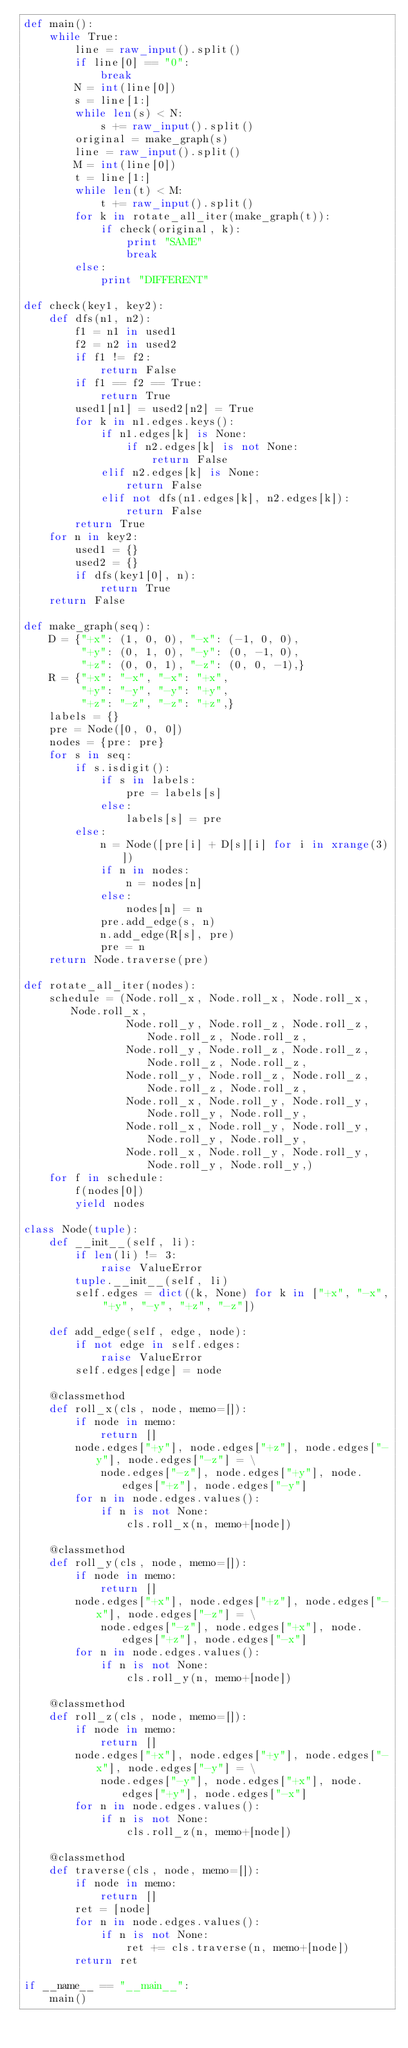<code> <loc_0><loc_0><loc_500><loc_500><_Python_>def main():
    while True:
        line = raw_input().split()
        if line[0] == "0":
            break
        N = int(line[0])
        s = line[1:]
        while len(s) < N:
            s += raw_input().split()
        original = make_graph(s)
        line = raw_input().split()
        M = int(line[0])
        t = line[1:]
        while len(t) < M:
            t += raw_input().split()
        for k in rotate_all_iter(make_graph(t)):
            if check(original, k):
                print "SAME"
                break
        else:
            print "DIFFERENT"

def check(key1, key2):
    def dfs(n1, n2):
        f1 = n1 in used1
        f2 = n2 in used2
        if f1 != f2:
            return False
        if f1 == f2 == True:
            return True
        used1[n1] = used2[n2] = True
        for k in n1.edges.keys():
            if n1.edges[k] is None:
                if n2.edges[k] is not None:
                    return False
            elif n2.edges[k] is None:
                return False
            elif not dfs(n1.edges[k], n2.edges[k]):
                return False
        return True
    for n in key2:
        used1 = {}
        used2 = {}
        if dfs(key1[0], n):
            return True
    return False

def make_graph(seq):
    D = {"+x": (1, 0, 0), "-x": (-1, 0, 0),
         "+y": (0, 1, 0), "-y": (0, -1, 0),
         "+z": (0, 0, 1), "-z": (0, 0, -1),}
    R = {"+x": "-x", "-x": "+x",
         "+y": "-y", "-y": "+y",
         "+z": "-z", "-z": "+z",}
    labels = {}
    pre = Node([0, 0, 0])
    nodes = {pre: pre}
    for s in seq:
        if s.isdigit():
            if s in labels:
                pre = labels[s]
            else:
                labels[s] = pre
        else:
            n = Node([pre[i] + D[s][i] for i in xrange(3)])
            if n in nodes:
                n = nodes[n]
            else:
                nodes[n] = n
            pre.add_edge(s, n)
            n.add_edge(R[s], pre)
            pre = n
    return Node.traverse(pre)

def rotate_all_iter(nodes):
    schedule = (Node.roll_x, Node.roll_x, Node.roll_x, Node.roll_x, 
                Node.roll_y, Node.roll_z, Node.roll_z, Node.roll_z, Node.roll_z,
                Node.roll_y, Node.roll_z, Node.roll_z, Node.roll_z, Node.roll_z,
                Node.roll_y, Node.roll_z, Node.roll_z, Node.roll_z, Node.roll_z,
                Node.roll_x, Node.roll_y, Node.roll_y, Node.roll_y, Node.roll_y,
                Node.roll_x, Node.roll_y, Node.roll_y, Node.roll_y, Node.roll_y,
                Node.roll_x, Node.roll_y, Node.roll_y, Node.roll_y, Node.roll_y,)
    for f in schedule:
        f(nodes[0])
        yield nodes

class Node(tuple):
    def __init__(self, li):
        if len(li) != 3:
            raise ValueError
        tuple.__init__(self, li)
        self.edges = dict((k, None) for k in ["+x", "-x", "+y", "-y", "+z", "-z"])
        
    def add_edge(self, edge, node):
        if not edge in self.edges:
            raise ValueError
        self.edges[edge] = node

    @classmethod
    def roll_x(cls, node, memo=[]):
        if node in memo:
            return []
        node.edges["+y"], node.edges["+z"], node.edges["-y"], node.edges["-z"] = \
            node.edges["-z"], node.edges["+y"], node.edges["+z"], node.edges["-y"]
        for n in node.edges.values():
            if n is not None:
                cls.roll_x(n, memo+[node])

    @classmethod
    def roll_y(cls, node, memo=[]):
        if node in memo:
            return []
        node.edges["+x"], node.edges["+z"], node.edges["-x"], node.edges["-z"] = \
            node.edges["-z"], node.edges["+x"], node.edges["+z"], node.edges["-x"]
        for n in node.edges.values():
            if n is not None:
                cls.roll_y(n, memo+[node])

    @classmethod
    def roll_z(cls, node, memo=[]):
        if node in memo:
            return []
        node.edges["+x"], node.edges["+y"], node.edges["-x"], node.edges["-y"] = \
            node.edges["-y"], node.edges["+x"], node.edges["+y"], node.edges["-x"]
        for n in node.edges.values():
            if n is not None:
                cls.roll_z(n, memo+[node])

    @classmethod
    def traverse(cls, node, memo=[]):
        if node in memo:
            return []
        ret = [node]
        for n in node.edges.values():
            if n is not None:
                ret += cls.traverse(n, memo+[node])
        return ret

if __name__ == "__main__":
    main()</code> 